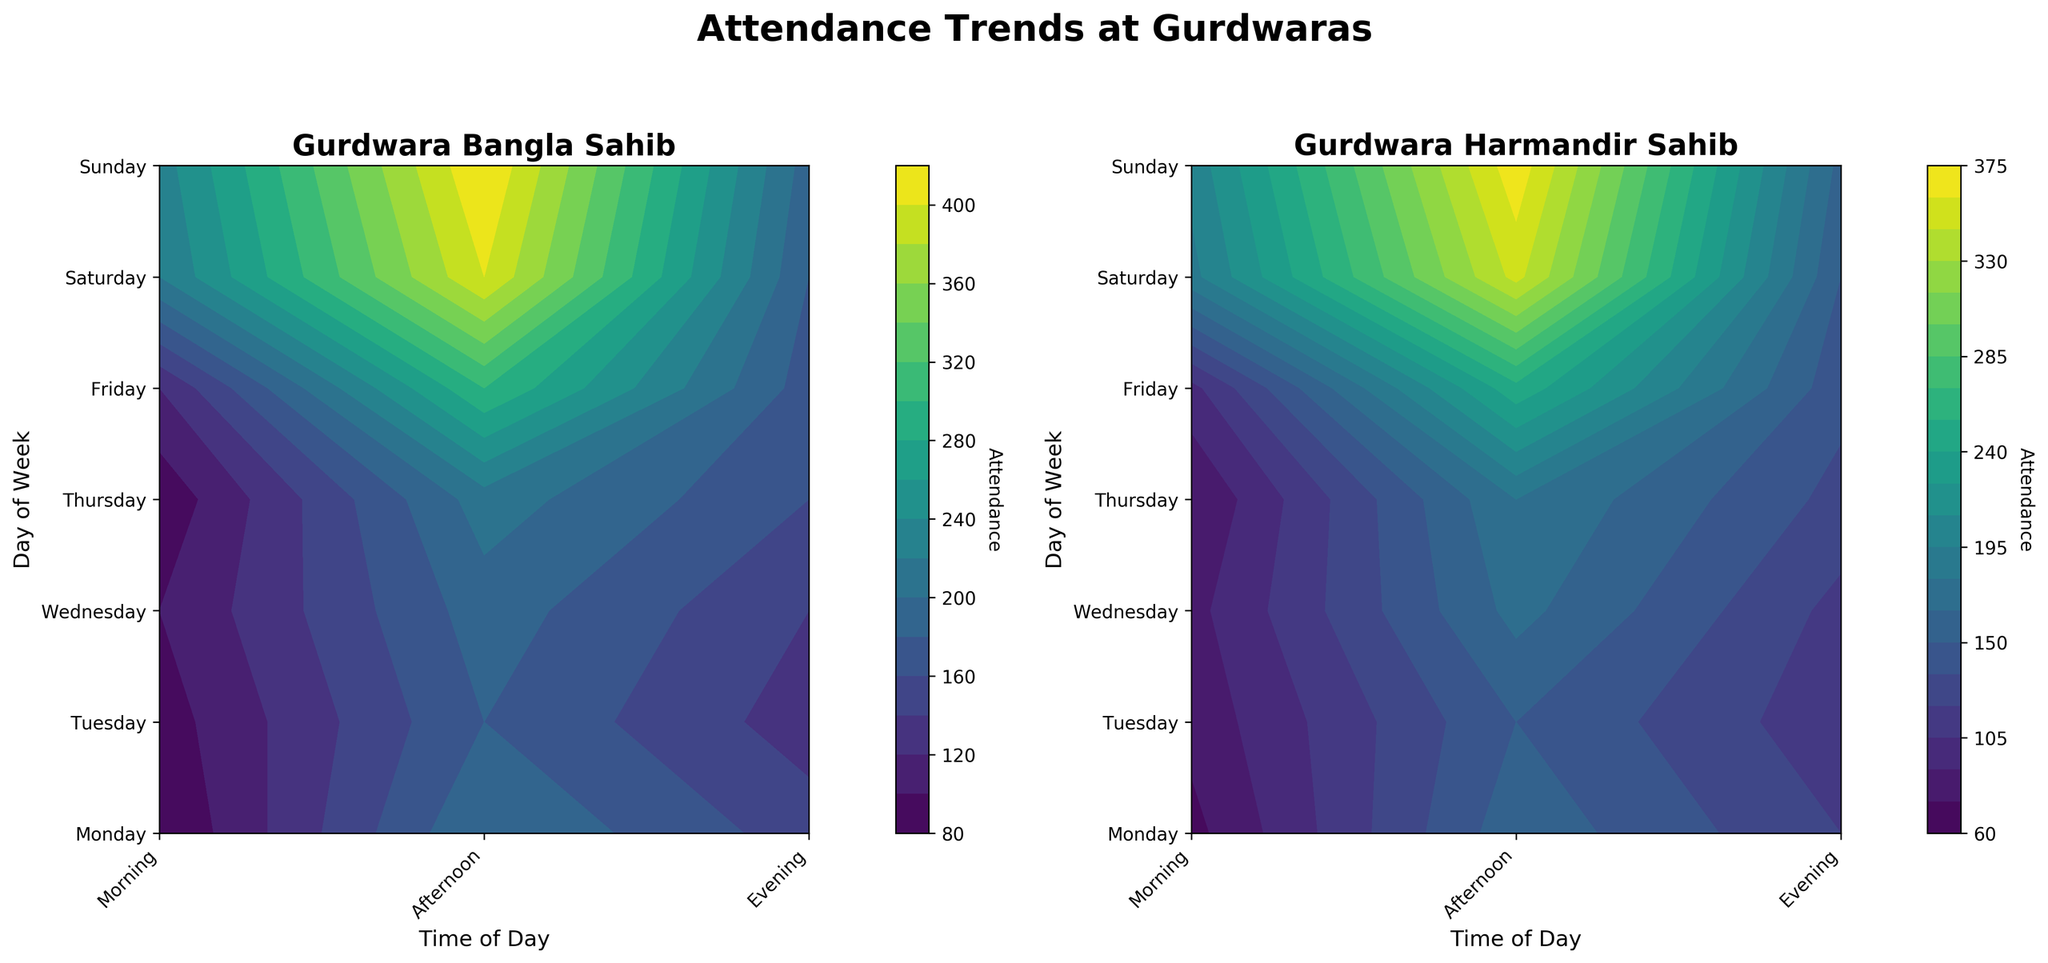Which Gurdwara has higher attendance on Sunday evening? Look at the "Sunday" and "Evening" positions on both subplots. The color indicates attendance level, and Gurdwara Bangla Sahib's color is more intense than Gurdwara Harmandir Sahib.
Answer: Gurdwara Bangla Sahib What is the difference in attendance between Wednesday morning and evening at Gurdwara Harmandir Sahib? Compare the color intensities at "Wednesday" row for "Morning" and "Evening" columns in the second subplot. Approximate values or use the color bar to find attendance levels: Morning ≈ 115, Evening ≈ 170. The difference is 170 - 115 = 55.
Answer: 55 Is there any day when the attendance at Gurdwara Bangla Sahib always increases from morning to evening? For Gurdwara Bangla Sahib subplot, check each day's row from morning to evening. Notice Saturday and Sunday attendance levels show an increasing trend from morning to evening based on color intensity and the corresponding values.
Answer: Yes, Saturday and Sunday Which time of the day generally has the lowest attendance at Gurdwara Harmandir Sahib? Look at the least intense color patches in the Gurdwara Harmandir Sahib subplot. "Afternoon" typically shows lower intensity colors compared to "Morning" and "Evening".
Answer: Afternoon On which day does Gurdwara Bangla Sahib have the highest evening attendance? For Gurdwara Bangla Sahib subplot, check the "Evening" column. The brightest color appears on Sunday evening. Verify this with the color bar, noting evening attendance value for Sunday is the highest.
Answer: Sunday How does Friday evening attendance at Gurdwara Harmandir Sahib compare to Tuesday evening attendance at the same place? In the Gurdwara Harmandir Sahib subplot, compare the color intensities at "Friday" and "Tuesday" rows for "Evening" columns. The color on Friday evening is more intense than Tuesday evening. Use numerical values from the color bar for verification.
Answer: Higher What's the average attendance on Thursday across all times of the day at Gurdwara Bangla Sahib? Sum the approximate values for "Thursday" row in the Gurdwara Bangla Sahib subplot (Morning ≈ 160, Afternoon ≈ 85, Evening ≈ 210). Calculate the average: (160 + 85 + 210)/3 = 455/3 ≈ 151.67.
Answer: 151.67 Do both Gurdwaras have higher attendance on weekends compared to weekdays? Check Saturday and Sunday rows in both subplots. Compare color intensities with Monday to Friday rows. General observation shows weekends have higher attendance (brighter colors).
Answer: Yes Is there a time when both Gurdwaras experience their maximum attendance? Identify the brightest colors in both subplots. For Gurdwara Bangla Sahib, it’s Sunday evening. For Gurdwara Harmandir Sahib, it’s Sunday evening. Hence, both Gurdwaras have their maximum attendance on Sunday evening.
Answer: Yes, Sunday evening 